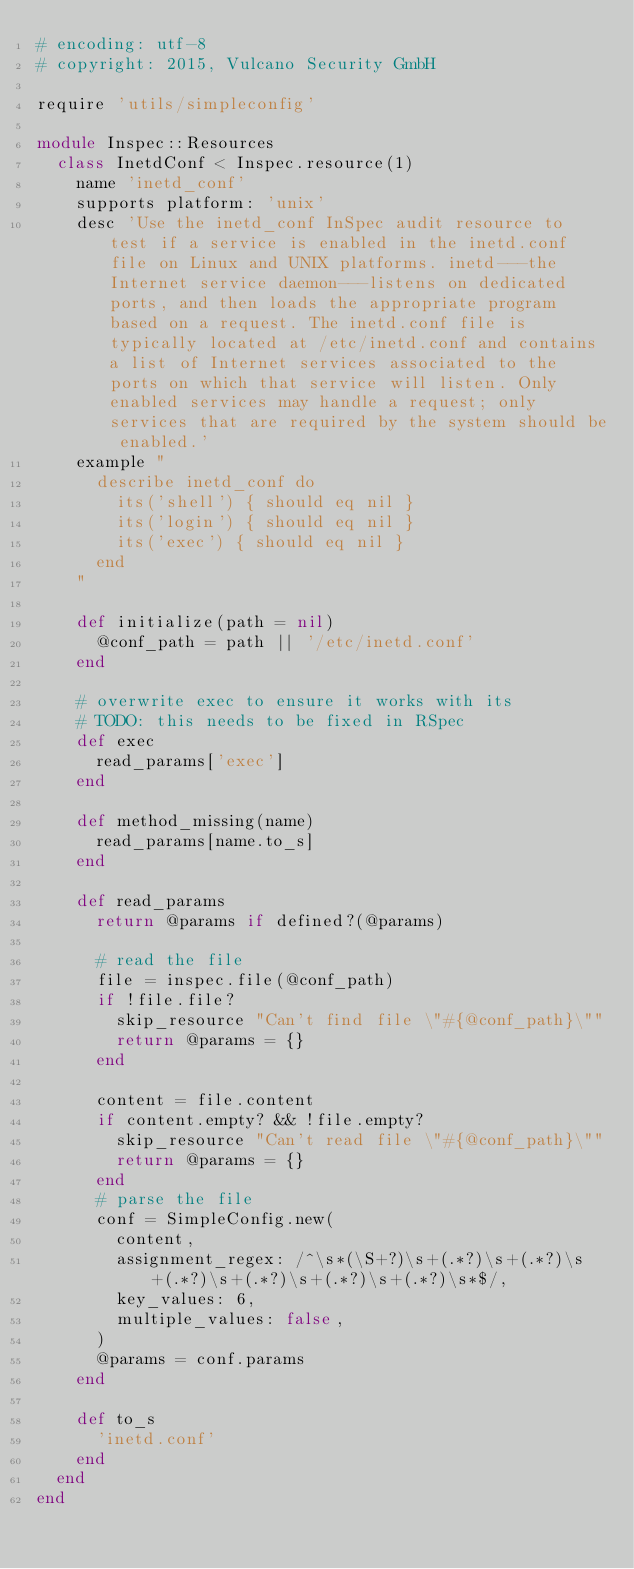<code> <loc_0><loc_0><loc_500><loc_500><_Ruby_># encoding: utf-8
# copyright: 2015, Vulcano Security GmbH

require 'utils/simpleconfig'

module Inspec::Resources
  class InetdConf < Inspec.resource(1)
    name 'inetd_conf'
    supports platform: 'unix'
    desc 'Use the inetd_conf InSpec audit resource to test if a service is enabled in the inetd.conf file on Linux and UNIX platforms. inetd---the Internet service daemon---listens on dedicated ports, and then loads the appropriate program based on a request. The inetd.conf file is typically located at /etc/inetd.conf and contains a list of Internet services associated to the ports on which that service will listen. Only enabled services may handle a request; only services that are required by the system should be enabled.'
    example "
      describe inetd_conf do
        its('shell') { should eq nil }
        its('login') { should eq nil }
        its('exec') { should eq nil }
      end
    "

    def initialize(path = nil)
      @conf_path = path || '/etc/inetd.conf'
    end

    # overwrite exec to ensure it works with its
    # TODO: this needs to be fixed in RSpec
    def exec
      read_params['exec']
    end

    def method_missing(name)
      read_params[name.to_s]
    end

    def read_params
      return @params if defined?(@params)

      # read the file
      file = inspec.file(@conf_path)
      if !file.file?
        skip_resource "Can't find file \"#{@conf_path}\""
        return @params = {}
      end

      content = file.content
      if content.empty? && !file.empty?
        skip_resource "Can't read file \"#{@conf_path}\""
        return @params = {}
      end
      # parse the file
      conf = SimpleConfig.new(
        content,
        assignment_regex: /^\s*(\S+?)\s+(.*?)\s+(.*?)\s+(.*?)\s+(.*?)\s+(.*?)\s+(.*?)\s*$/,
        key_values: 6,
        multiple_values: false,
      )
      @params = conf.params
    end

    def to_s
      'inetd.conf'
    end
  end
end
</code> 